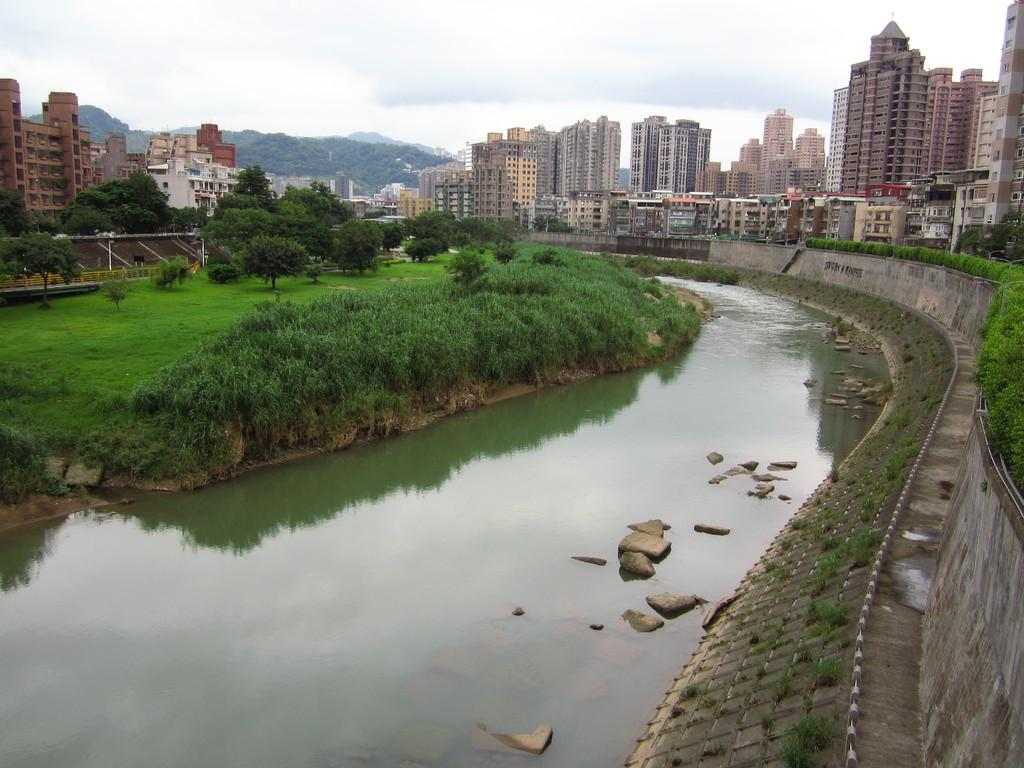What is the main feature in the middle of the image? There is a lake in the middle of the image. What type of vegetation can be seen in the image? There is grass and trees in the image. What is visible on the other side of the lake? There are buildings on the other side of the lake. Where is the bomb located in the image? There is no bomb present in the image. Can you see a basketball court near the lake in the image? There is no basketball court visible in the image. 